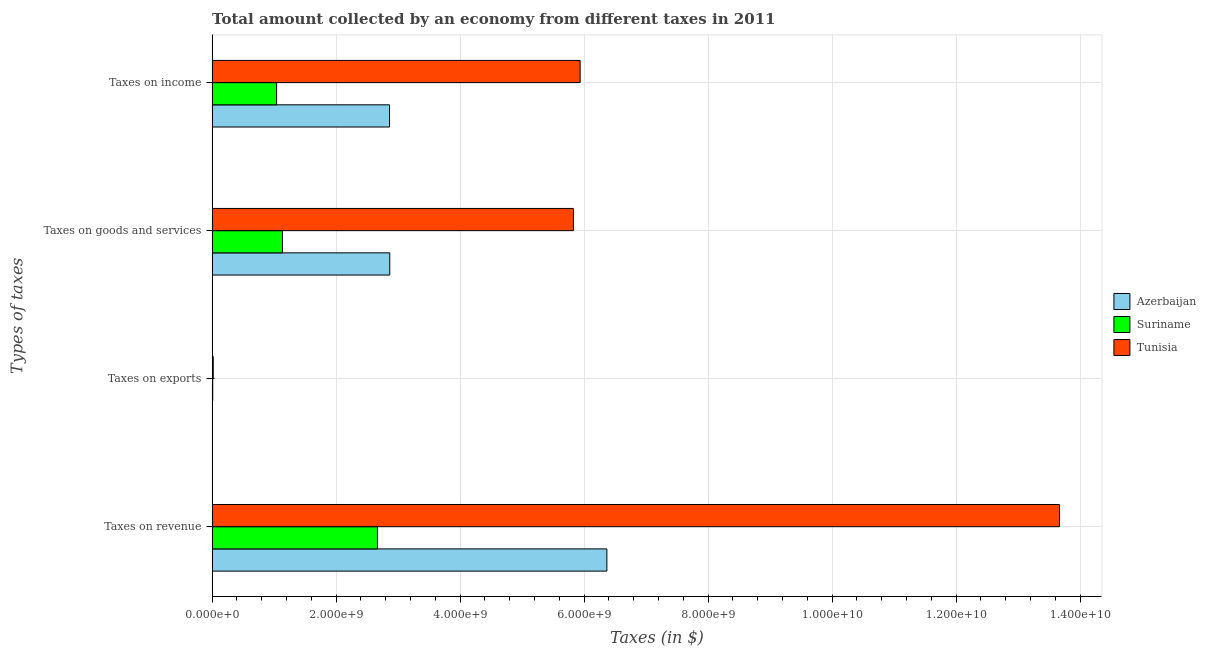What is the label of the 4th group of bars from the top?
Your answer should be compact. Taxes on revenue. What is the amount collected as tax on income in Azerbaijan?
Offer a very short reply. 2.86e+09. Across all countries, what is the maximum amount collected as tax on revenue?
Offer a very short reply. 1.37e+1. Across all countries, what is the minimum amount collected as tax on revenue?
Keep it short and to the point. 2.67e+09. In which country was the amount collected as tax on income maximum?
Your answer should be compact. Tunisia. In which country was the amount collected as tax on income minimum?
Provide a succinct answer. Suriname. What is the total amount collected as tax on exports in the graph?
Your answer should be very brief. 2.81e+07. What is the difference between the amount collected as tax on goods in Tunisia and that in Suriname?
Provide a short and direct response. 4.69e+09. What is the difference between the amount collected as tax on revenue in Suriname and the amount collected as tax on goods in Tunisia?
Give a very brief answer. -3.16e+09. What is the average amount collected as tax on exports per country?
Keep it short and to the point. 9.38e+06. What is the difference between the amount collected as tax on exports and amount collected as tax on revenue in Azerbaijan?
Your response must be concise. -6.37e+09. What is the ratio of the amount collected as tax on exports in Azerbaijan to that in Tunisia?
Keep it short and to the point. 0.01. Is the amount collected as tax on goods in Tunisia less than that in Azerbaijan?
Your answer should be compact. No. What is the difference between the highest and the second highest amount collected as tax on exports?
Your answer should be very brief. 8.07e+06. What is the difference between the highest and the lowest amount collected as tax on income?
Give a very brief answer. 4.90e+09. Is the sum of the amount collected as tax on income in Azerbaijan and Suriname greater than the maximum amount collected as tax on revenue across all countries?
Offer a very short reply. No. What does the 1st bar from the top in Taxes on revenue represents?
Your response must be concise. Tunisia. What does the 3rd bar from the bottom in Taxes on income represents?
Your answer should be very brief. Tunisia. How many bars are there?
Offer a terse response. 12. Are all the bars in the graph horizontal?
Your answer should be compact. Yes. What is the difference between two consecutive major ticks on the X-axis?
Offer a very short reply. 2.00e+09. Does the graph contain grids?
Provide a short and direct response. Yes. Where does the legend appear in the graph?
Your answer should be very brief. Center right. How are the legend labels stacked?
Make the answer very short. Vertical. What is the title of the graph?
Keep it short and to the point. Total amount collected by an economy from different taxes in 2011. Does "Iraq" appear as one of the legend labels in the graph?
Provide a succinct answer. No. What is the label or title of the X-axis?
Your answer should be compact. Taxes (in $). What is the label or title of the Y-axis?
Your answer should be compact. Types of taxes. What is the Taxes (in $) in Azerbaijan in Taxes on revenue?
Your response must be concise. 6.37e+09. What is the Taxes (in $) in Suriname in Taxes on revenue?
Offer a very short reply. 2.67e+09. What is the Taxes (in $) of Tunisia in Taxes on revenue?
Your response must be concise. 1.37e+1. What is the Taxes (in $) in Suriname in Taxes on exports?
Your answer should be very brief. 9.93e+06. What is the Taxes (in $) of Tunisia in Taxes on exports?
Make the answer very short. 1.80e+07. What is the Taxes (in $) of Azerbaijan in Taxes on goods and services?
Your answer should be very brief. 2.87e+09. What is the Taxes (in $) in Suriname in Taxes on goods and services?
Ensure brevity in your answer.  1.13e+09. What is the Taxes (in $) of Tunisia in Taxes on goods and services?
Ensure brevity in your answer.  5.83e+09. What is the Taxes (in $) of Azerbaijan in Taxes on income?
Make the answer very short. 2.86e+09. What is the Taxes (in $) of Suriname in Taxes on income?
Make the answer very short. 1.04e+09. What is the Taxes (in $) in Tunisia in Taxes on income?
Make the answer very short. 5.94e+09. Across all Types of taxes, what is the maximum Taxes (in $) of Azerbaijan?
Ensure brevity in your answer.  6.37e+09. Across all Types of taxes, what is the maximum Taxes (in $) of Suriname?
Make the answer very short. 2.67e+09. Across all Types of taxes, what is the maximum Taxes (in $) of Tunisia?
Offer a terse response. 1.37e+1. Across all Types of taxes, what is the minimum Taxes (in $) in Suriname?
Ensure brevity in your answer.  9.93e+06. Across all Types of taxes, what is the minimum Taxes (in $) in Tunisia?
Provide a short and direct response. 1.80e+07. What is the total Taxes (in $) in Azerbaijan in the graph?
Keep it short and to the point. 1.21e+1. What is the total Taxes (in $) in Suriname in the graph?
Give a very brief answer. 4.85e+09. What is the total Taxes (in $) of Tunisia in the graph?
Offer a very short reply. 2.54e+1. What is the difference between the Taxes (in $) of Azerbaijan in Taxes on revenue and that in Taxes on exports?
Your answer should be very brief. 6.37e+09. What is the difference between the Taxes (in $) of Suriname in Taxes on revenue and that in Taxes on exports?
Offer a very short reply. 2.66e+09. What is the difference between the Taxes (in $) of Tunisia in Taxes on revenue and that in Taxes on exports?
Your answer should be compact. 1.36e+1. What is the difference between the Taxes (in $) of Azerbaijan in Taxes on revenue and that in Taxes on goods and services?
Provide a short and direct response. 3.50e+09. What is the difference between the Taxes (in $) of Suriname in Taxes on revenue and that in Taxes on goods and services?
Give a very brief answer. 1.53e+09. What is the difference between the Taxes (in $) of Tunisia in Taxes on revenue and that in Taxes on goods and services?
Ensure brevity in your answer.  7.84e+09. What is the difference between the Taxes (in $) of Azerbaijan in Taxes on revenue and that in Taxes on income?
Offer a terse response. 3.51e+09. What is the difference between the Taxes (in $) in Suriname in Taxes on revenue and that in Taxes on income?
Your response must be concise. 1.63e+09. What is the difference between the Taxes (in $) of Tunisia in Taxes on revenue and that in Taxes on income?
Your response must be concise. 7.73e+09. What is the difference between the Taxes (in $) in Azerbaijan in Taxes on exports and that in Taxes on goods and services?
Keep it short and to the point. -2.86e+09. What is the difference between the Taxes (in $) in Suriname in Taxes on exports and that in Taxes on goods and services?
Offer a terse response. -1.12e+09. What is the difference between the Taxes (in $) of Tunisia in Taxes on exports and that in Taxes on goods and services?
Your answer should be compact. -5.81e+09. What is the difference between the Taxes (in $) in Azerbaijan in Taxes on exports and that in Taxes on income?
Offer a very short reply. -2.86e+09. What is the difference between the Taxes (in $) of Suriname in Taxes on exports and that in Taxes on income?
Offer a very short reply. -1.03e+09. What is the difference between the Taxes (in $) of Tunisia in Taxes on exports and that in Taxes on income?
Make the answer very short. -5.92e+09. What is the difference between the Taxes (in $) of Azerbaijan in Taxes on goods and services and that in Taxes on income?
Keep it short and to the point. 3.50e+06. What is the difference between the Taxes (in $) of Suriname in Taxes on goods and services and that in Taxes on income?
Your answer should be compact. 9.34e+07. What is the difference between the Taxes (in $) in Tunisia in Taxes on goods and services and that in Taxes on income?
Give a very brief answer. -1.08e+08. What is the difference between the Taxes (in $) in Azerbaijan in Taxes on revenue and the Taxes (in $) in Suriname in Taxes on exports?
Offer a terse response. 6.36e+09. What is the difference between the Taxes (in $) in Azerbaijan in Taxes on revenue and the Taxes (in $) in Tunisia in Taxes on exports?
Offer a terse response. 6.35e+09. What is the difference between the Taxes (in $) of Suriname in Taxes on revenue and the Taxes (in $) of Tunisia in Taxes on exports?
Your answer should be compact. 2.65e+09. What is the difference between the Taxes (in $) in Azerbaijan in Taxes on revenue and the Taxes (in $) in Suriname in Taxes on goods and services?
Ensure brevity in your answer.  5.23e+09. What is the difference between the Taxes (in $) of Azerbaijan in Taxes on revenue and the Taxes (in $) of Tunisia in Taxes on goods and services?
Give a very brief answer. 5.40e+08. What is the difference between the Taxes (in $) of Suriname in Taxes on revenue and the Taxes (in $) of Tunisia in Taxes on goods and services?
Your response must be concise. -3.16e+09. What is the difference between the Taxes (in $) in Azerbaijan in Taxes on revenue and the Taxes (in $) in Suriname in Taxes on income?
Your answer should be very brief. 5.33e+09. What is the difference between the Taxes (in $) of Azerbaijan in Taxes on revenue and the Taxes (in $) of Tunisia in Taxes on income?
Your response must be concise. 4.31e+08. What is the difference between the Taxes (in $) in Suriname in Taxes on revenue and the Taxes (in $) in Tunisia in Taxes on income?
Offer a very short reply. -3.27e+09. What is the difference between the Taxes (in $) of Azerbaijan in Taxes on exports and the Taxes (in $) of Suriname in Taxes on goods and services?
Your answer should be very brief. -1.13e+09. What is the difference between the Taxes (in $) in Azerbaijan in Taxes on exports and the Taxes (in $) in Tunisia in Taxes on goods and services?
Your response must be concise. -5.83e+09. What is the difference between the Taxes (in $) in Suriname in Taxes on exports and the Taxes (in $) in Tunisia in Taxes on goods and services?
Ensure brevity in your answer.  -5.82e+09. What is the difference between the Taxes (in $) of Azerbaijan in Taxes on exports and the Taxes (in $) of Suriname in Taxes on income?
Keep it short and to the point. -1.04e+09. What is the difference between the Taxes (in $) in Azerbaijan in Taxes on exports and the Taxes (in $) in Tunisia in Taxes on income?
Your answer should be very brief. -5.94e+09. What is the difference between the Taxes (in $) in Suriname in Taxes on exports and the Taxes (in $) in Tunisia in Taxes on income?
Your answer should be compact. -5.93e+09. What is the difference between the Taxes (in $) in Azerbaijan in Taxes on goods and services and the Taxes (in $) in Suriname in Taxes on income?
Offer a very short reply. 1.82e+09. What is the difference between the Taxes (in $) in Azerbaijan in Taxes on goods and services and the Taxes (in $) in Tunisia in Taxes on income?
Provide a succinct answer. -3.07e+09. What is the difference between the Taxes (in $) in Suriname in Taxes on goods and services and the Taxes (in $) in Tunisia in Taxes on income?
Offer a very short reply. -4.80e+09. What is the average Taxes (in $) of Azerbaijan per Types of taxes?
Ensure brevity in your answer.  3.02e+09. What is the average Taxes (in $) of Suriname per Types of taxes?
Ensure brevity in your answer.  1.21e+09. What is the average Taxes (in $) in Tunisia per Types of taxes?
Make the answer very short. 6.36e+09. What is the difference between the Taxes (in $) of Azerbaijan and Taxes (in $) of Suriname in Taxes on revenue?
Ensure brevity in your answer.  3.70e+09. What is the difference between the Taxes (in $) in Azerbaijan and Taxes (in $) in Tunisia in Taxes on revenue?
Provide a succinct answer. -7.30e+09. What is the difference between the Taxes (in $) of Suriname and Taxes (in $) of Tunisia in Taxes on revenue?
Give a very brief answer. -1.10e+1. What is the difference between the Taxes (in $) of Azerbaijan and Taxes (in $) of Suriname in Taxes on exports?
Your answer should be compact. -9.73e+06. What is the difference between the Taxes (in $) of Azerbaijan and Taxes (in $) of Tunisia in Taxes on exports?
Give a very brief answer. -1.78e+07. What is the difference between the Taxes (in $) of Suriname and Taxes (in $) of Tunisia in Taxes on exports?
Offer a terse response. -8.07e+06. What is the difference between the Taxes (in $) of Azerbaijan and Taxes (in $) of Suriname in Taxes on goods and services?
Provide a short and direct response. 1.73e+09. What is the difference between the Taxes (in $) of Azerbaijan and Taxes (in $) of Tunisia in Taxes on goods and services?
Make the answer very short. -2.96e+09. What is the difference between the Taxes (in $) in Suriname and Taxes (in $) in Tunisia in Taxes on goods and services?
Offer a very short reply. -4.69e+09. What is the difference between the Taxes (in $) of Azerbaijan and Taxes (in $) of Suriname in Taxes on income?
Make the answer very short. 1.82e+09. What is the difference between the Taxes (in $) of Azerbaijan and Taxes (in $) of Tunisia in Taxes on income?
Offer a very short reply. -3.07e+09. What is the difference between the Taxes (in $) in Suriname and Taxes (in $) in Tunisia in Taxes on income?
Make the answer very short. -4.90e+09. What is the ratio of the Taxes (in $) in Azerbaijan in Taxes on revenue to that in Taxes on exports?
Your response must be concise. 3.18e+04. What is the ratio of the Taxes (in $) in Suriname in Taxes on revenue to that in Taxes on exports?
Your response must be concise. 268.53. What is the ratio of the Taxes (in $) in Tunisia in Taxes on revenue to that in Taxes on exports?
Give a very brief answer. 759.33. What is the ratio of the Taxes (in $) in Azerbaijan in Taxes on revenue to that in Taxes on goods and services?
Ensure brevity in your answer.  2.22. What is the ratio of the Taxes (in $) of Suriname in Taxes on revenue to that in Taxes on goods and services?
Your response must be concise. 2.35. What is the ratio of the Taxes (in $) of Tunisia in Taxes on revenue to that in Taxes on goods and services?
Offer a very short reply. 2.35. What is the ratio of the Taxes (in $) in Azerbaijan in Taxes on revenue to that in Taxes on income?
Provide a short and direct response. 2.22. What is the ratio of the Taxes (in $) of Suriname in Taxes on revenue to that in Taxes on income?
Provide a succinct answer. 2.56. What is the ratio of the Taxes (in $) in Tunisia in Taxes on revenue to that in Taxes on income?
Your answer should be very brief. 2.3. What is the ratio of the Taxes (in $) in Suriname in Taxes on exports to that in Taxes on goods and services?
Keep it short and to the point. 0.01. What is the ratio of the Taxes (in $) of Tunisia in Taxes on exports to that in Taxes on goods and services?
Offer a very short reply. 0. What is the ratio of the Taxes (in $) of Suriname in Taxes on exports to that in Taxes on income?
Your answer should be compact. 0.01. What is the ratio of the Taxes (in $) of Tunisia in Taxes on exports to that in Taxes on income?
Ensure brevity in your answer.  0. What is the ratio of the Taxes (in $) in Suriname in Taxes on goods and services to that in Taxes on income?
Provide a succinct answer. 1.09. What is the ratio of the Taxes (in $) of Tunisia in Taxes on goods and services to that in Taxes on income?
Your response must be concise. 0.98. What is the difference between the highest and the second highest Taxes (in $) in Azerbaijan?
Provide a short and direct response. 3.50e+09. What is the difference between the highest and the second highest Taxes (in $) in Suriname?
Your answer should be very brief. 1.53e+09. What is the difference between the highest and the second highest Taxes (in $) in Tunisia?
Offer a very short reply. 7.73e+09. What is the difference between the highest and the lowest Taxes (in $) in Azerbaijan?
Give a very brief answer. 6.37e+09. What is the difference between the highest and the lowest Taxes (in $) of Suriname?
Provide a short and direct response. 2.66e+09. What is the difference between the highest and the lowest Taxes (in $) of Tunisia?
Your answer should be compact. 1.36e+1. 